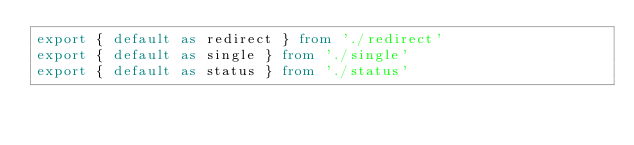Convert code to text. <code><loc_0><loc_0><loc_500><loc_500><_TypeScript_>export { default as redirect } from './redirect'
export { default as single } from './single'
export { default as status } from './status'
</code> 